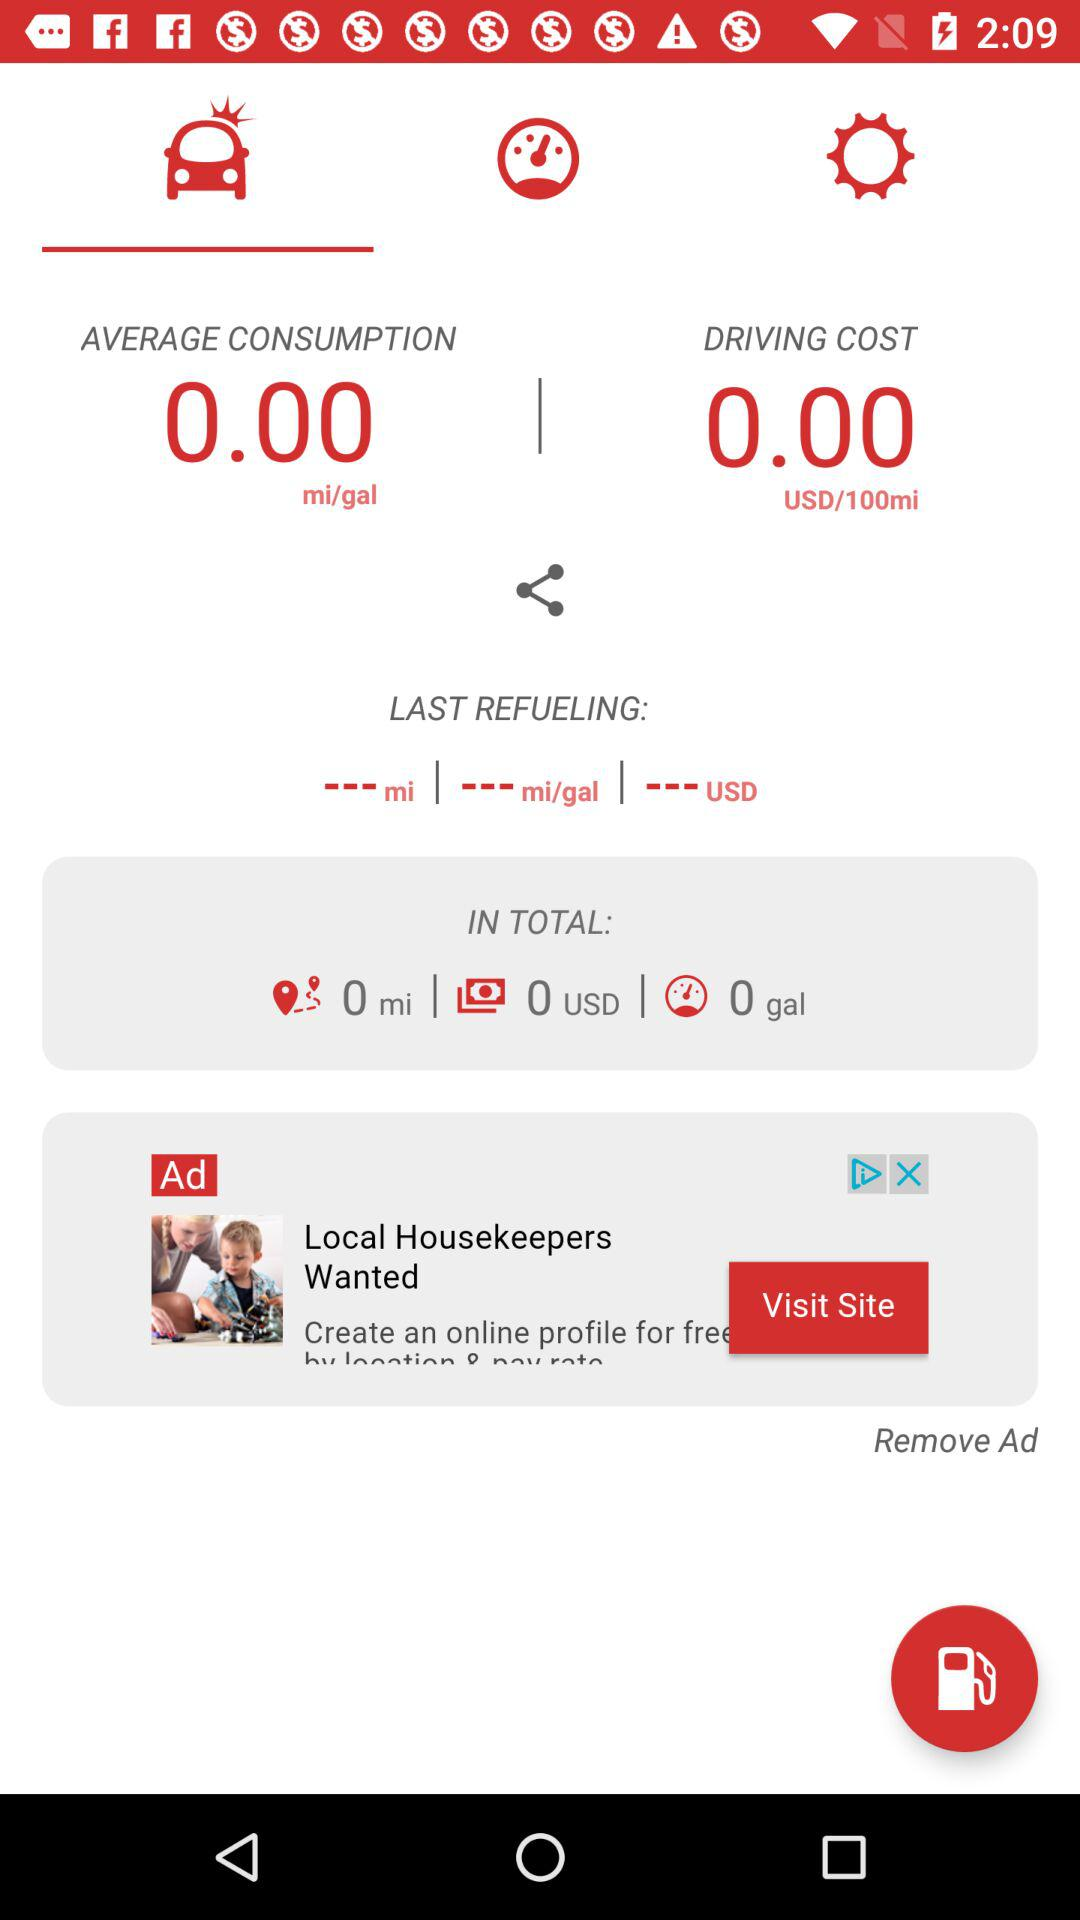How much is the driving cost? The cost is 0.00 USD/100 miles. 